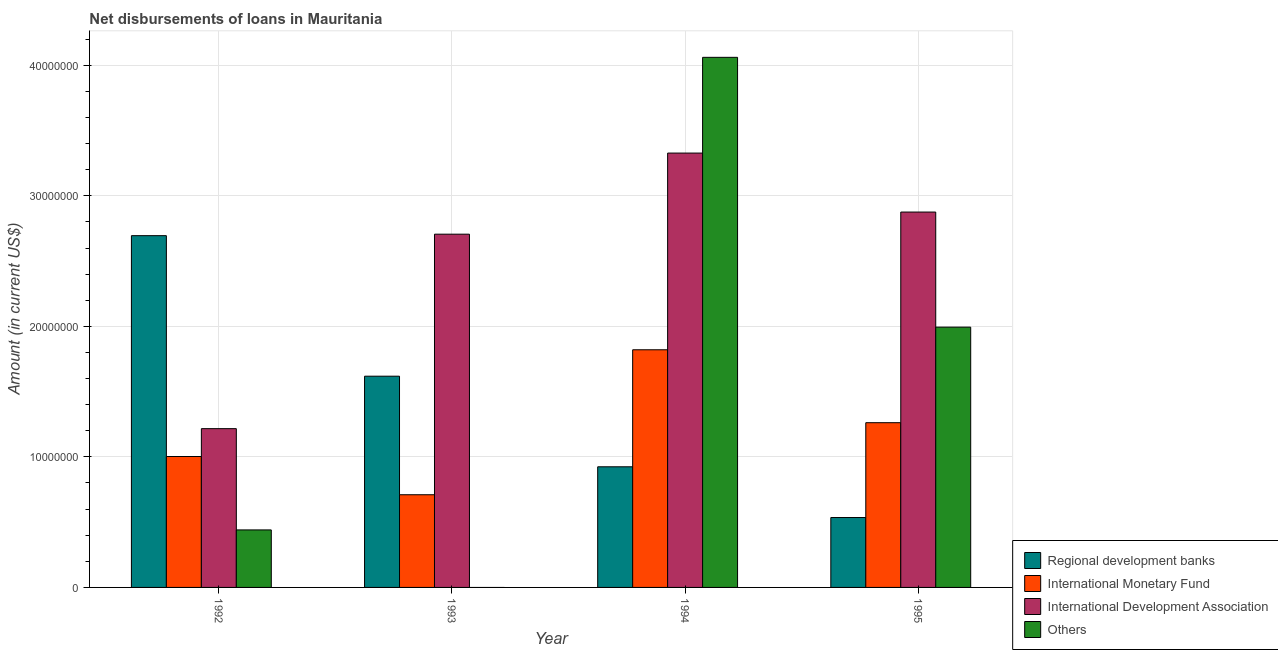Are the number of bars on each tick of the X-axis equal?
Ensure brevity in your answer.  No. What is the amount of loan disimbursed by regional development banks in 1993?
Your response must be concise. 1.62e+07. Across all years, what is the maximum amount of loan disimbursed by international monetary fund?
Offer a terse response. 1.82e+07. Across all years, what is the minimum amount of loan disimbursed by international monetary fund?
Give a very brief answer. 7.10e+06. What is the total amount of loan disimbursed by international monetary fund in the graph?
Ensure brevity in your answer.  4.80e+07. What is the difference between the amount of loan disimbursed by other organisations in 1992 and that in 1995?
Offer a terse response. -1.55e+07. What is the difference between the amount of loan disimbursed by regional development banks in 1995 and the amount of loan disimbursed by other organisations in 1994?
Give a very brief answer. -3.89e+06. What is the average amount of loan disimbursed by international development association per year?
Provide a short and direct response. 2.53e+07. In the year 1992, what is the difference between the amount of loan disimbursed by international development association and amount of loan disimbursed by international monetary fund?
Ensure brevity in your answer.  0. In how many years, is the amount of loan disimbursed by international development association greater than 16000000 US$?
Your response must be concise. 3. What is the ratio of the amount of loan disimbursed by international development association in 1993 to that in 1995?
Give a very brief answer. 0.94. What is the difference between the highest and the second highest amount of loan disimbursed by international monetary fund?
Give a very brief answer. 5.58e+06. What is the difference between the highest and the lowest amount of loan disimbursed by regional development banks?
Provide a succinct answer. 2.16e+07. How many bars are there?
Ensure brevity in your answer.  15. What is the difference between two consecutive major ticks on the Y-axis?
Your answer should be compact. 1.00e+07. Does the graph contain any zero values?
Give a very brief answer. Yes. Does the graph contain grids?
Your answer should be very brief. Yes. Where does the legend appear in the graph?
Keep it short and to the point. Bottom right. What is the title of the graph?
Your response must be concise. Net disbursements of loans in Mauritania. What is the label or title of the X-axis?
Make the answer very short. Year. What is the label or title of the Y-axis?
Your answer should be compact. Amount (in current US$). What is the Amount (in current US$) in Regional development banks in 1992?
Your response must be concise. 2.69e+07. What is the Amount (in current US$) of International Monetary Fund in 1992?
Ensure brevity in your answer.  1.00e+07. What is the Amount (in current US$) of International Development Association in 1992?
Make the answer very short. 1.22e+07. What is the Amount (in current US$) of Others in 1992?
Provide a succinct answer. 4.40e+06. What is the Amount (in current US$) of Regional development banks in 1993?
Give a very brief answer. 1.62e+07. What is the Amount (in current US$) of International Monetary Fund in 1993?
Your response must be concise. 7.10e+06. What is the Amount (in current US$) of International Development Association in 1993?
Provide a succinct answer. 2.71e+07. What is the Amount (in current US$) of Regional development banks in 1994?
Your answer should be very brief. 9.24e+06. What is the Amount (in current US$) in International Monetary Fund in 1994?
Your answer should be compact. 1.82e+07. What is the Amount (in current US$) in International Development Association in 1994?
Provide a short and direct response. 3.33e+07. What is the Amount (in current US$) of Others in 1994?
Your answer should be very brief. 4.06e+07. What is the Amount (in current US$) of Regional development banks in 1995?
Offer a very short reply. 5.36e+06. What is the Amount (in current US$) in International Monetary Fund in 1995?
Keep it short and to the point. 1.26e+07. What is the Amount (in current US$) in International Development Association in 1995?
Your answer should be compact. 2.88e+07. What is the Amount (in current US$) of Others in 1995?
Offer a terse response. 1.99e+07. Across all years, what is the maximum Amount (in current US$) of Regional development banks?
Provide a short and direct response. 2.69e+07. Across all years, what is the maximum Amount (in current US$) in International Monetary Fund?
Provide a succinct answer. 1.82e+07. Across all years, what is the maximum Amount (in current US$) of International Development Association?
Give a very brief answer. 3.33e+07. Across all years, what is the maximum Amount (in current US$) in Others?
Offer a very short reply. 4.06e+07. Across all years, what is the minimum Amount (in current US$) of Regional development banks?
Give a very brief answer. 5.36e+06. Across all years, what is the minimum Amount (in current US$) of International Monetary Fund?
Provide a short and direct response. 7.10e+06. Across all years, what is the minimum Amount (in current US$) of International Development Association?
Your answer should be very brief. 1.22e+07. Across all years, what is the minimum Amount (in current US$) in Others?
Ensure brevity in your answer.  0. What is the total Amount (in current US$) of Regional development banks in the graph?
Provide a succinct answer. 5.77e+07. What is the total Amount (in current US$) of International Monetary Fund in the graph?
Make the answer very short. 4.80e+07. What is the total Amount (in current US$) in International Development Association in the graph?
Provide a succinct answer. 1.01e+08. What is the total Amount (in current US$) of Others in the graph?
Provide a short and direct response. 6.50e+07. What is the difference between the Amount (in current US$) of Regional development banks in 1992 and that in 1993?
Ensure brevity in your answer.  1.08e+07. What is the difference between the Amount (in current US$) in International Monetary Fund in 1992 and that in 1993?
Keep it short and to the point. 2.93e+06. What is the difference between the Amount (in current US$) of International Development Association in 1992 and that in 1993?
Provide a short and direct response. -1.49e+07. What is the difference between the Amount (in current US$) in Regional development banks in 1992 and that in 1994?
Make the answer very short. 1.77e+07. What is the difference between the Amount (in current US$) in International Monetary Fund in 1992 and that in 1994?
Offer a very short reply. -8.18e+06. What is the difference between the Amount (in current US$) in International Development Association in 1992 and that in 1994?
Ensure brevity in your answer.  -2.11e+07. What is the difference between the Amount (in current US$) in Others in 1992 and that in 1994?
Your answer should be very brief. -3.62e+07. What is the difference between the Amount (in current US$) in Regional development banks in 1992 and that in 1995?
Give a very brief answer. 2.16e+07. What is the difference between the Amount (in current US$) in International Monetary Fund in 1992 and that in 1995?
Your answer should be very brief. -2.59e+06. What is the difference between the Amount (in current US$) of International Development Association in 1992 and that in 1995?
Make the answer very short. -1.66e+07. What is the difference between the Amount (in current US$) of Others in 1992 and that in 1995?
Your answer should be compact. -1.55e+07. What is the difference between the Amount (in current US$) in Regional development banks in 1993 and that in 1994?
Your answer should be very brief. 6.94e+06. What is the difference between the Amount (in current US$) in International Monetary Fund in 1993 and that in 1994?
Your answer should be compact. -1.11e+07. What is the difference between the Amount (in current US$) in International Development Association in 1993 and that in 1994?
Make the answer very short. -6.21e+06. What is the difference between the Amount (in current US$) in Regional development banks in 1993 and that in 1995?
Your answer should be very brief. 1.08e+07. What is the difference between the Amount (in current US$) in International Monetary Fund in 1993 and that in 1995?
Your answer should be compact. -5.52e+06. What is the difference between the Amount (in current US$) of International Development Association in 1993 and that in 1995?
Provide a succinct answer. -1.70e+06. What is the difference between the Amount (in current US$) in Regional development banks in 1994 and that in 1995?
Keep it short and to the point. 3.89e+06. What is the difference between the Amount (in current US$) in International Monetary Fund in 1994 and that in 1995?
Ensure brevity in your answer.  5.58e+06. What is the difference between the Amount (in current US$) of International Development Association in 1994 and that in 1995?
Your answer should be compact. 4.52e+06. What is the difference between the Amount (in current US$) of Others in 1994 and that in 1995?
Ensure brevity in your answer.  2.07e+07. What is the difference between the Amount (in current US$) of Regional development banks in 1992 and the Amount (in current US$) of International Monetary Fund in 1993?
Give a very brief answer. 1.98e+07. What is the difference between the Amount (in current US$) in Regional development banks in 1992 and the Amount (in current US$) in International Development Association in 1993?
Your answer should be very brief. -1.14e+05. What is the difference between the Amount (in current US$) of International Monetary Fund in 1992 and the Amount (in current US$) of International Development Association in 1993?
Make the answer very short. -1.70e+07. What is the difference between the Amount (in current US$) of Regional development banks in 1992 and the Amount (in current US$) of International Monetary Fund in 1994?
Keep it short and to the point. 8.74e+06. What is the difference between the Amount (in current US$) in Regional development banks in 1992 and the Amount (in current US$) in International Development Association in 1994?
Offer a terse response. -6.33e+06. What is the difference between the Amount (in current US$) of Regional development banks in 1992 and the Amount (in current US$) of Others in 1994?
Offer a terse response. -1.37e+07. What is the difference between the Amount (in current US$) of International Monetary Fund in 1992 and the Amount (in current US$) of International Development Association in 1994?
Your answer should be very brief. -2.32e+07. What is the difference between the Amount (in current US$) of International Monetary Fund in 1992 and the Amount (in current US$) of Others in 1994?
Your response must be concise. -3.06e+07. What is the difference between the Amount (in current US$) in International Development Association in 1992 and the Amount (in current US$) in Others in 1994?
Offer a terse response. -2.84e+07. What is the difference between the Amount (in current US$) in Regional development banks in 1992 and the Amount (in current US$) in International Monetary Fund in 1995?
Keep it short and to the point. 1.43e+07. What is the difference between the Amount (in current US$) of Regional development banks in 1992 and the Amount (in current US$) of International Development Association in 1995?
Give a very brief answer. -1.81e+06. What is the difference between the Amount (in current US$) of Regional development banks in 1992 and the Amount (in current US$) of Others in 1995?
Provide a succinct answer. 7.01e+06. What is the difference between the Amount (in current US$) of International Monetary Fund in 1992 and the Amount (in current US$) of International Development Association in 1995?
Offer a terse response. -1.87e+07. What is the difference between the Amount (in current US$) in International Monetary Fund in 1992 and the Amount (in current US$) in Others in 1995?
Provide a short and direct response. -9.91e+06. What is the difference between the Amount (in current US$) in International Development Association in 1992 and the Amount (in current US$) in Others in 1995?
Give a very brief answer. -7.78e+06. What is the difference between the Amount (in current US$) in Regional development banks in 1993 and the Amount (in current US$) in International Monetary Fund in 1994?
Your answer should be very brief. -2.02e+06. What is the difference between the Amount (in current US$) in Regional development banks in 1993 and the Amount (in current US$) in International Development Association in 1994?
Provide a short and direct response. -1.71e+07. What is the difference between the Amount (in current US$) of Regional development banks in 1993 and the Amount (in current US$) of Others in 1994?
Provide a succinct answer. -2.44e+07. What is the difference between the Amount (in current US$) in International Monetary Fund in 1993 and the Amount (in current US$) in International Development Association in 1994?
Your answer should be very brief. -2.62e+07. What is the difference between the Amount (in current US$) of International Monetary Fund in 1993 and the Amount (in current US$) of Others in 1994?
Ensure brevity in your answer.  -3.35e+07. What is the difference between the Amount (in current US$) in International Development Association in 1993 and the Amount (in current US$) in Others in 1994?
Provide a short and direct response. -1.35e+07. What is the difference between the Amount (in current US$) in Regional development banks in 1993 and the Amount (in current US$) in International Monetary Fund in 1995?
Ensure brevity in your answer.  3.56e+06. What is the difference between the Amount (in current US$) in Regional development banks in 1993 and the Amount (in current US$) in International Development Association in 1995?
Your answer should be very brief. -1.26e+07. What is the difference between the Amount (in current US$) in Regional development banks in 1993 and the Amount (in current US$) in Others in 1995?
Ensure brevity in your answer.  -3.76e+06. What is the difference between the Amount (in current US$) of International Monetary Fund in 1993 and the Amount (in current US$) of International Development Association in 1995?
Offer a very short reply. -2.17e+07. What is the difference between the Amount (in current US$) of International Monetary Fund in 1993 and the Amount (in current US$) of Others in 1995?
Offer a very short reply. -1.28e+07. What is the difference between the Amount (in current US$) in International Development Association in 1993 and the Amount (in current US$) in Others in 1995?
Your answer should be compact. 7.12e+06. What is the difference between the Amount (in current US$) of Regional development banks in 1994 and the Amount (in current US$) of International Monetary Fund in 1995?
Your answer should be very brief. -3.38e+06. What is the difference between the Amount (in current US$) in Regional development banks in 1994 and the Amount (in current US$) in International Development Association in 1995?
Ensure brevity in your answer.  -1.95e+07. What is the difference between the Amount (in current US$) of Regional development banks in 1994 and the Amount (in current US$) of Others in 1995?
Your answer should be compact. -1.07e+07. What is the difference between the Amount (in current US$) in International Monetary Fund in 1994 and the Amount (in current US$) in International Development Association in 1995?
Your answer should be very brief. -1.06e+07. What is the difference between the Amount (in current US$) in International Monetary Fund in 1994 and the Amount (in current US$) in Others in 1995?
Make the answer very short. -1.74e+06. What is the difference between the Amount (in current US$) of International Development Association in 1994 and the Amount (in current US$) of Others in 1995?
Provide a succinct answer. 1.33e+07. What is the average Amount (in current US$) of Regional development banks per year?
Make the answer very short. 1.44e+07. What is the average Amount (in current US$) in International Monetary Fund per year?
Offer a very short reply. 1.20e+07. What is the average Amount (in current US$) of International Development Association per year?
Give a very brief answer. 2.53e+07. What is the average Amount (in current US$) in Others per year?
Your answer should be very brief. 1.62e+07. In the year 1992, what is the difference between the Amount (in current US$) in Regional development banks and Amount (in current US$) in International Monetary Fund?
Offer a very short reply. 1.69e+07. In the year 1992, what is the difference between the Amount (in current US$) of Regional development banks and Amount (in current US$) of International Development Association?
Your response must be concise. 1.48e+07. In the year 1992, what is the difference between the Amount (in current US$) of Regional development banks and Amount (in current US$) of Others?
Offer a terse response. 2.25e+07. In the year 1992, what is the difference between the Amount (in current US$) in International Monetary Fund and Amount (in current US$) in International Development Association?
Ensure brevity in your answer.  -2.14e+06. In the year 1992, what is the difference between the Amount (in current US$) of International Monetary Fund and Amount (in current US$) of Others?
Your answer should be compact. 5.62e+06. In the year 1992, what is the difference between the Amount (in current US$) of International Development Association and Amount (in current US$) of Others?
Your response must be concise. 7.76e+06. In the year 1993, what is the difference between the Amount (in current US$) in Regional development banks and Amount (in current US$) in International Monetary Fund?
Keep it short and to the point. 9.08e+06. In the year 1993, what is the difference between the Amount (in current US$) of Regional development banks and Amount (in current US$) of International Development Association?
Make the answer very short. -1.09e+07. In the year 1993, what is the difference between the Amount (in current US$) of International Monetary Fund and Amount (in current US$) of International Development Association?
Offer a very short reply. -2.00e+07. In the year 1994, what is the difference between the Amount (in current US$) of Regional development banks and Amount (in current US$) of International Monetary Fund?
Your answer should be compact. -8.96e+06. In the year 1994, what is the difference between the Amount (in current US$) in Regional development banks and Amount (in current US$) in International Development Association?
Your answer should be very brief. -2.40e+07. In the year 1994, what is the difference between the Amount (in current US$) in Regional development banks and Amount (in current US$) in Others?
Your response must be concise. -3.14e+07. In the year 1994, what is the difference between the Amount (in current US$) of International Monetary Fund and Amount (in current US$) of International Development Association?
Offer a terse response. -1.51e+07. In the year 1994, what is the difference between the Amount (in current US$) of International Monetary Fund and Amount (in current US$) of Others?
Ensure brevity in your answer.  -2.24e+07. In the year 1994, what is the difference between the Amount (in current US$) in International Development Association and Amount (in current US$) in Others?
Provide a succinct answer. -7.33e+06. In the year 1995, what is the difference between the Amount (in current US$) of Regional development banks and Amount (in current US$) of International Monetary Fund?
Provide a succinct answer. -7.26e+06. In the year 1995, what is the difference between the Amount (in current US$) of Regional development banks and Amount (in current US$) of International Development Association?
Your response must be concise. -2.34e+07. In the year 1995, what is the difference between the Amount (in current US$) in Regional development banks and Amount (in current US$) in Others?
Provide a succinct answer. -1.46e+07. In the year 1995, what is the difference between the Amount (in current US$) of International Monetary Fund and Amount (in current US$) of International Development Association?
Your answer should be compact. -1.61e+07. In the year 1995, what is the difference between the Amount (in current US$) in International Monetary Fund and Amount (in current US$) in Others?
Make the answer very short. -7.32e+06. In the year 1995, what is the difference between the Amount (in current US$) in International Development Association and Amount (in current US$) in Others?
Provide a succinct answer. 8.82e+06. What is the ratio of the Amount (in current US$) of Regional development banks in 1992 to that in 1993?
Your answer should be very brief. 1.67. What is the ratio of the Amount (in current US$) in International Monetary Fund in 1992 to that in 1993?
Your response must be concise. 1.41. What is the ratio of the Amount (in current US$) of International Development Association in 1992 to that in 1993?
Offer a terse response. 0.45. What is the ratio of the Amount (in current US$) of Regional development banks in 1992 to that in 1994?
Offer a very short reply. 2.92. What is the ratio of the Amount (in current US$) in International Monetary Fund in 1992 to that in 1994?
Ensure brevity in your answer.  0.55. What is the ratio of the Amount (in current US$) of International Development Association in 1992 to that in 1994?
Keep it short and to the point. 0.37. What is the ratio of the Amount (in current US$) of Others in 1992 to that in 1994?
Provide a succinct answer. 0.11. What is the ratio of the Amount (in current US$) of Regional development banks in 1992 to that in 1995?
Ensure brevity in your answer.  5.03. What is the ratio of the Amount (in current US$) in International Monetary Fund in 1992 to that in 1995?
Offer a terse response. 0.79. What is the ratio of the Amount (in current US$) of International Development Association in 1992 to that in 1995?
Make the answer very short. 0.42. What is the ratio of the Amount (in current US$) in Others in 1992 to that in 1995?
Your response must be concise. 0.22. What is the ratio of the Amount (in current US$) of Regional development banks in 1993 to that in 1994?
Give a very brief answer. 1.75. What is the ratio of the Amount (in current US$) of International Monetary Fund in 1993 to that in 1994?
Keep it short and to the point. 0.39. What is the ratio of the Amount (in current US$) of International Development Association in 1993 to that in 1994?
Your response must be concise. 0.81. What is the ratio of the Amount (in current US$) of Regional development banks in 1993 to that in 1995?
Your answer should be compact. 3.02. What is the ratio of the Amount (in current US$) of International Monetary Fund in 1993 to that in 1995?
Your response must be concise. 0.56. What is the ratio of the Amount (in current US$) in International Development Association in 1993 to that in 1995?
Provide a succinct answer. 0.94. What is the ratio of the Amount (in current US$) in Regional development banks in 1994 to that in 1995?
Offer a very short reply. 1.73. What is the ratio of the Amount (in current US$) in International Monetary Fund in 1994 to that in 1995?
Provide a short and direct response. 1.44. What is the ratio of the Amount (in current US$) in International Development Association in 1994 to that in 1995?
Your answer should be very brief. 1.16. What is the ratio of the Amount (in current US$) in Others in 1994 to that in 1995?
Provide a short and direct response. 2.04. What is the difference between the highest and the second highest Amount (in current US$) in Regional development banks?
Provide a short and direct response. 1.08e+07. What is the difference between the highest and the second highest Amount (in current US$) in International Monetary Fund?
Offer a terse response. 5.58e+06. What is the difference between the highest and the second highest Amount (in current US$) in International Development Association?
Provide a succinct answer. 4.52e+06. What is the difference between the highest and the second highest Amount (in current US$) of Others?
Offer a very short reply. 2.07e+07. What is the difference between the highest and the lowest Amount (in current US$) in Regional development banks?
Your response must be concise. 2.16e+07. What is the difference between the highest and the lowest Amount (in current US$) of International Monetary Fund?
Your response must be concise. 1.11e+07. What is the difference between the highest and the lowest Amount (in current US$) of International Development Association?
Provide a succinct answer. 2.11e+07. What is the difference between the highest and the lowest Amount (in current US$) of Others?
Provide a succinct answer. 4.06e+07. 